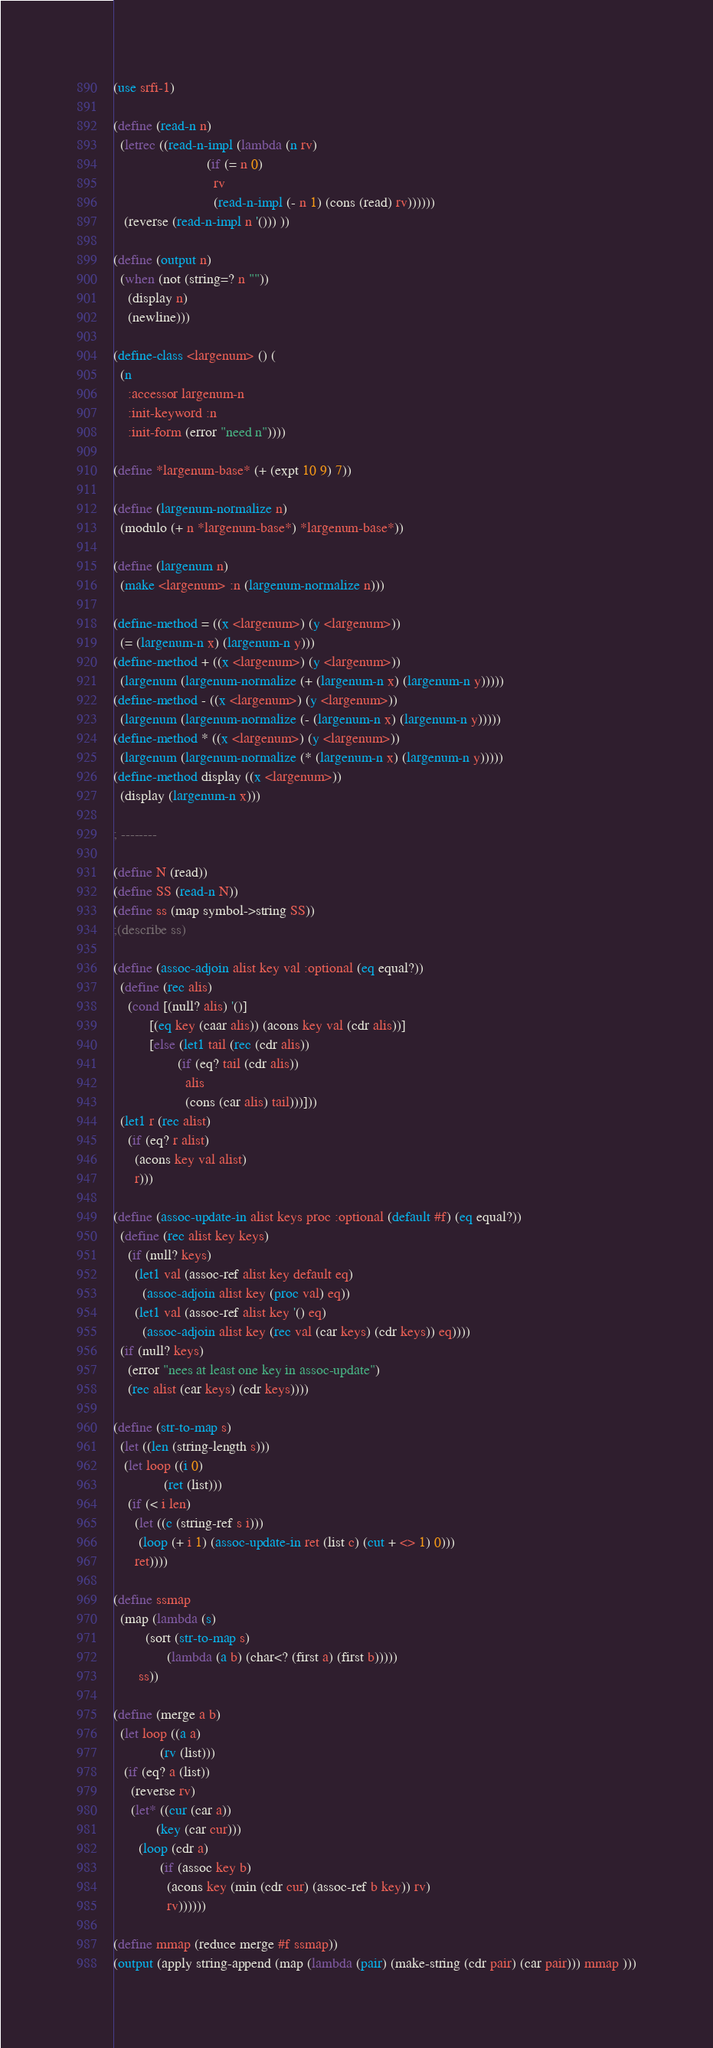Convert code to text. <code><loc_0><loc_0><loc_500><loc_500><_Scheme_>(use srfi-1)

(define (read-n n)
  (letrec ((read-n-impl (lambda (n rv)
                          (if (= n 0)
                            rv
                            (read-n-impl (- n 1) (cons (read) rv))))))
   (reverse (read-n-impl n '())) ))

(define (output n)
  (when (not (string=? n ""))
    (display n) 
    (newline)))

(define-class <largenum> () (
  (n
    :accessor largenum-n
    :init-keyword :n
    :init-form (error "need n"))))

(define *largenum-base* (+ (expt 10 9) 7))

(define (largenum-normalize n)
  (modulo (+ n *largenum-base*) *largenum-base*))

(define (largenum n)
  (make <largenum> :n (largenum-normalize n)))

(define-method = ((x <largenum>) (y <largenum>))
  (= (largenum-n x) (largenum-n y)))
(define-method + ((x <largenum>) (y <largenum>))
  (largenum (largenum-normalize (+ (largenum-n x) (largenum-n y)))))
(define-method - ((x <largenum>) (y <largenum>))
  (largenum (largenum-normalize (- (largenum-n x) (largenum-n y)))))
(define-method * ((x <largenum>) (y <largenum>))
  (largenum (largenum-normalize (* (largenum-n x) (largenum-n y)))))
(define-method display ((x <largenum>))
  (display (largenum-n x)))

; --------

(define N (read))
(define SS (read-n N))
(define ss (map symbol->string SS))
;(describe ss)

(define (assoc-adjoin alist key val :optional (eq equal?))
  (define (rec alis)
    (cond [(null? alis) '()]
          [(eq key (caar alis)) (acons key val (cdr alis))]
          [else (let1 tail (rec (cdr alis))
                  (if (eq? tail (cdr alis))
                    alis
                    (cons (car alis) tail)))]))
  (let1 r (rec alist)
    (if (eq? r alist)
      (acons key val alist)
      r)))

(define (assoc-update-in alist keys proc :optional (default #f) (eq equal?))
  (define (rec alist key keys)
    (if (null? keys)
      (let1 val (assoc-ref alist key default eq)
        (assoc-adjoin alist key (proc val) eq))
      (let1 val (assoc-ref alist key '() eq)
        (assoc-adjoin alist key (rec val (car keys) (cdr keys)) eq))))
  (if (null? keys)
    (error "nees at least one key in assoc-update")
    (rec alist (car keys) (cdr keys))))

(define (str-to-map s)
  (let ((len (string-length s)))
   (let loop ((i 0)
              (ret (list)))
    (if (< i len)
      (let ((c (string-ref s i)))
       (loop (+ i 1) (assoc-update-in ret (list c) (cut + <> 1) 0)))
      ret))))

(define ssmap
  (map (lambda (s)
         (sort (str-to-map s)
               (lambda (a b) (char<? (first a) (first b)))))
       ss))

(define (merge a b)
  (let loop ((a a)
             (rv (list)))
   (if (eq? a (list))
     (reverse rv)
     (let* ((cur (car a))
            (key (car cur)))
       (loop (cdr a)
             (if (assoc key b)
               (acons key (min (cdr cur) (assoc-ref b key)) rv)
               rv))))))

(define mmap (reduce merge #f ssmap))
(output (apply string-append (map (lambda (pair) (make-string (cdr pair) (car pair))) mmap )))
</code> 